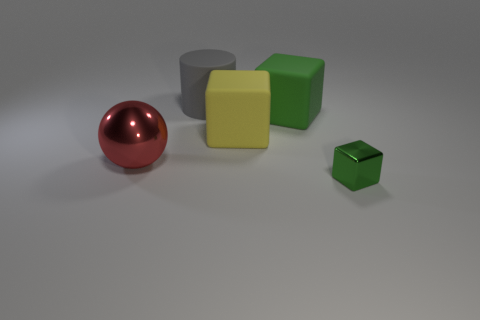There is a cylinder; does it have the same size as the green block that is in front of the large green matte block?
Provide a short and direct response. No. The green thing in front of the big red thing behind the green metal object is what shape?
Ensure brevity in your answer.  Cube. Are there fewer shiny cubes that are in front of the large red ball than tiny green cubes?
Give a very brief answer. No. The other matte thing that is the same color as the small thing is what shape?
Ensure brevity in your answer.  Cube. What number of rubber cylinders are the same size as the yellow thing?
Provide a short and direct response. 1. What shape is the metal object to the right of the gray matte cylinder?
Keep it short and to the point. Cube. Is the number of objects less than the number of cylinders?
Provide a succinct answer. No. Is there anything else that has the same color as the large matte cylinder?
Keep it short and to the point. No. What size is the green object that is behind the large yellow block?
Keep it short and to the point. Large. Are there more cylinders than blue cylinders?
Give a very brief answer. Yes. 